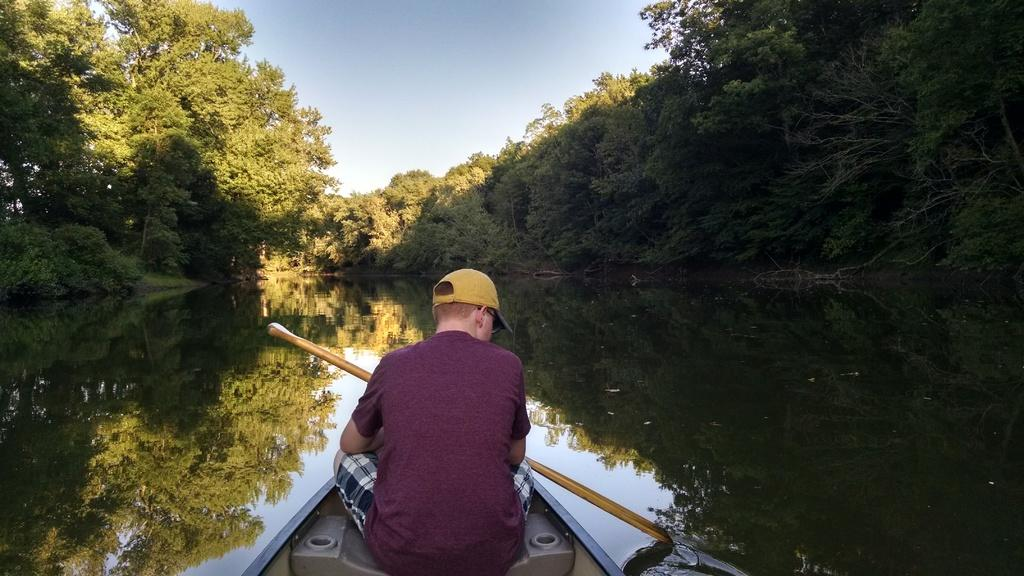What is the person in the image doing? The person is sitting on a boat and rowing it. What is the person sitting on in the image? The person is sitting on a boat. What can be seen in the background of the image? There are trees in the background of the image. What is the primary element in the image? The primary element in the image is water. What type of design can be seen on the kitten's fur in the image? There is no kitten present in the image, so there is no design on its fur. 